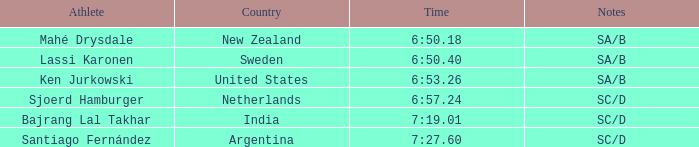What is listed in notes for the athlete, lassi karonen? SA/B. Could you parse the entire table? {'header': ['Athlete', 'Country', 'Time', 'Notes'], 'rows': [['Mahé Drysdale', 'New Zealand', '6:50.18', 'SA/B'], ['Lassi Karonen', 'Sweden', '6:50.40', 'SA/B'], ['Ken Jurkowski', 'United States', '6:53.26', 'SA/B'], ['Sjoerd Hamburger', 'Netherlands', '6:57.24', 'SC/D'], ['Bajrang Lal Takhar', 'India', '7:19.01', 'SC/D'], ['Santiago Fernández', 'Argentina', '7:27.60', 'SC/D']]} 